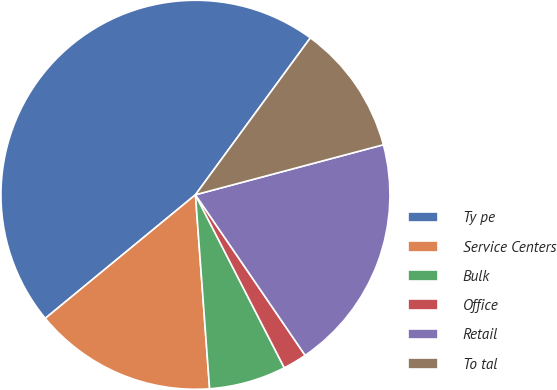Convert chart to OTSL. <chart><loc_0><loc_0><loc_500><loc_500><pie_chart><fcel>Ty pe<fcel>Service Centers<fcel>Bulk<fcel>Office<fcel>Retail<fcel>To tal<nl><fcel>46.02%<fcel>15.2%<fcel>6.39%<fcel>1.99%<fcel>19.6%<fcel>10.8%<nl></chart> 